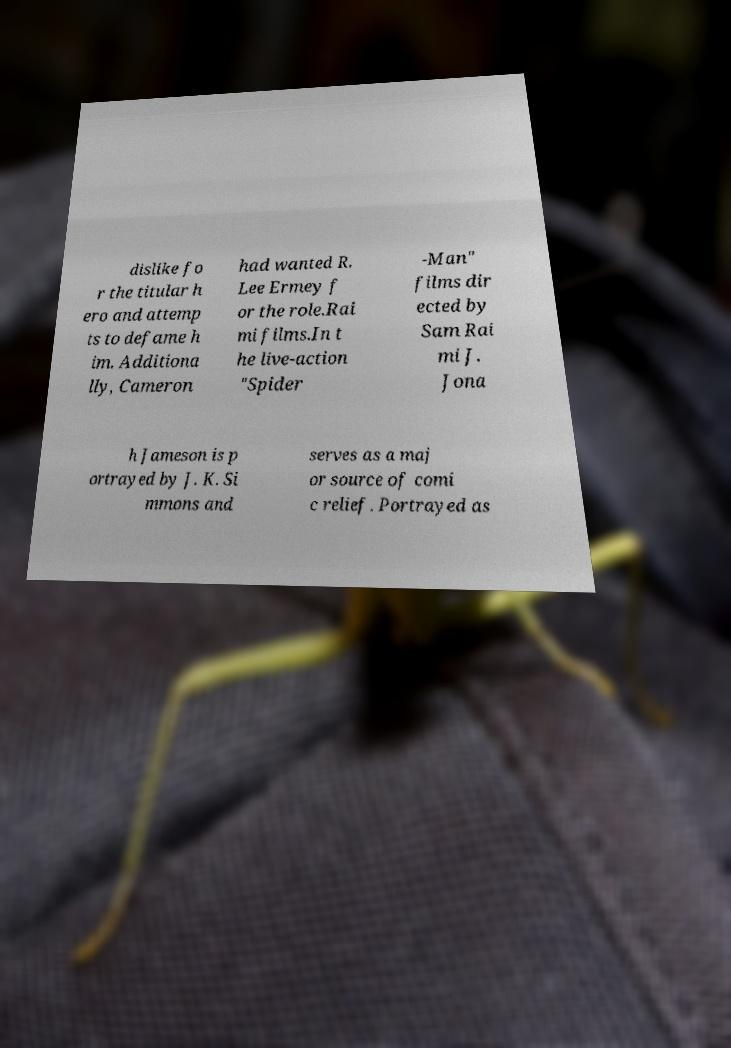What messages or text are displayed in this image? I need them in a readable, typed format. dislike fo r the titular h ero and attemp ts to defame h im. Additiona lly, Cameron had wanted R. Lee Ermey f or the role.Rai mi films.In t he live-action "Spider -Man" films dir ected by Sam Rai mi J. Jona h Jameson is p ortrayed by J. K. Si mmons and serves as a maj or source of comi c relief. Portrayed as 